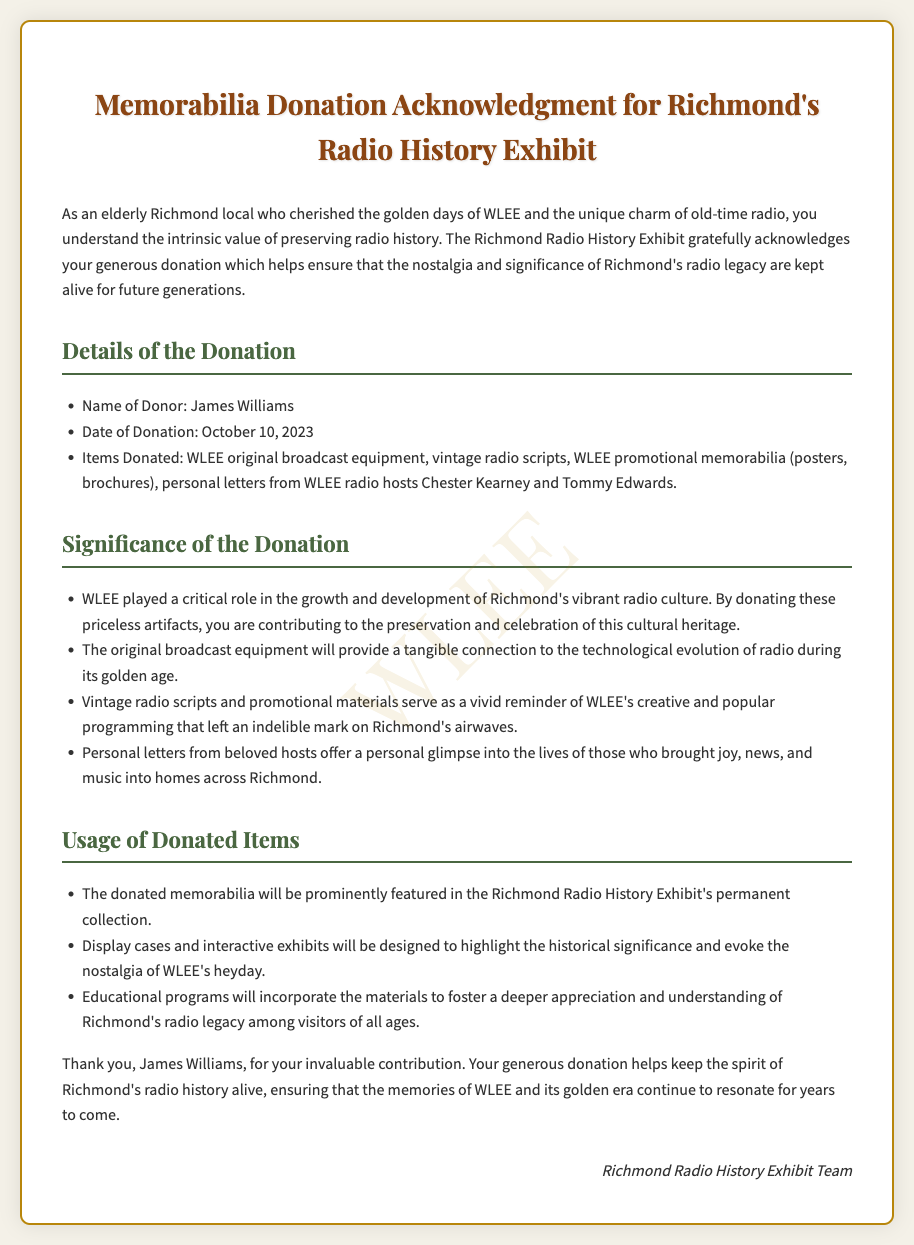What is the name of the donor? The name of the donor is explicitly mentioned in the document as James Williams.
Answer: James Williams When was the donation made? The date of donation provided in the document is October 10, 2023.
Answer: October 10, 2023 What items were donated? The document lists specific items donated such as WLEE original broadcast equipment and vintage radio scripts among others.
Answer: WLEE original broadcast equipment, vintage radio scripts, WLEE promotional memorabilia, personal letters What is one significance of the donation? The document states that the donated artifacts contribute to the preservation and celebration of Richmond's radio heritage.
Answer: Preservation of radio heritage How will the donated items be used? The document mentions that the memorabilia will be featured in the Richmond Radio History Exhibit's permanent collection.
Answer: Permanent collection Who signed the acknowledgment? The document indicates that the acknowledgment was signed by the Richmond Radio History Exhibit Team.
Answer: Richmond Radio History Exhibit Team What type of equipment was donated? The document refers specifically to original broadcast equipment as part of the donation.
Answer: Original broadcast equipment Why is this donation important for future generations? The document highlights that it helps keep the spirit of Richmond's radio history alive for future generations.
Answer: Keep the spirit alive 